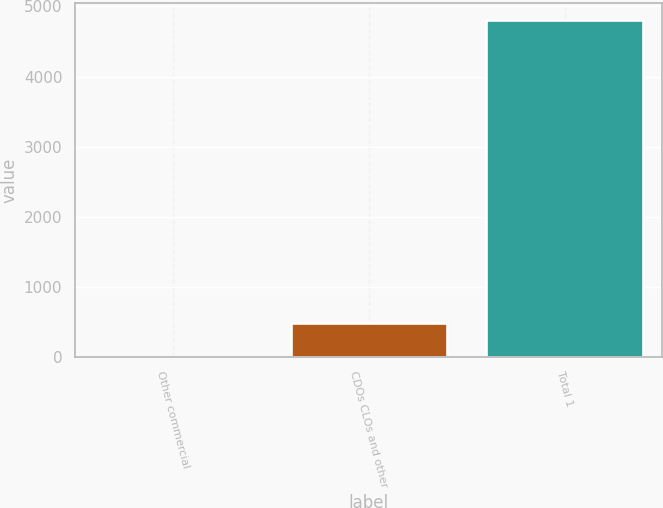Convert chart. <chart><loc_0><loc_0><loc_500><loc_500><bar_chart><fcel>Other commercial<fcel>CDOs CLOs and other<fcel>Total 1<nl><fcel>1<fcel>482.1<fcel>4812<nl></chart> 